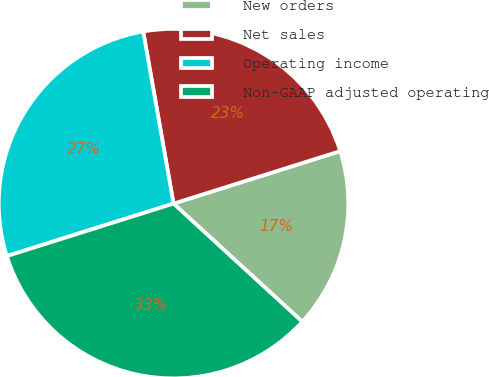<chart> <loc_0><loc_0><loc_500><loc_500><pie_chart><fcel>New orders<fcel>Net sales<fcel>Operating income<fcel>Non-GAAP adjusted operating<nl><fcel>16.67%<fcel>22.92%<fcel>27.08%<fcel>33.33%<nl></chart> 